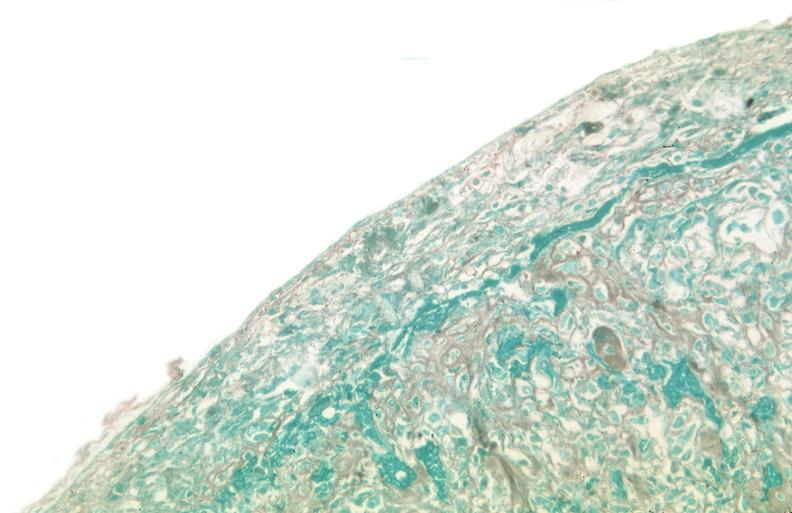does this person show pleura, talc reaction?
Answer the question using a single word or phrase. No 